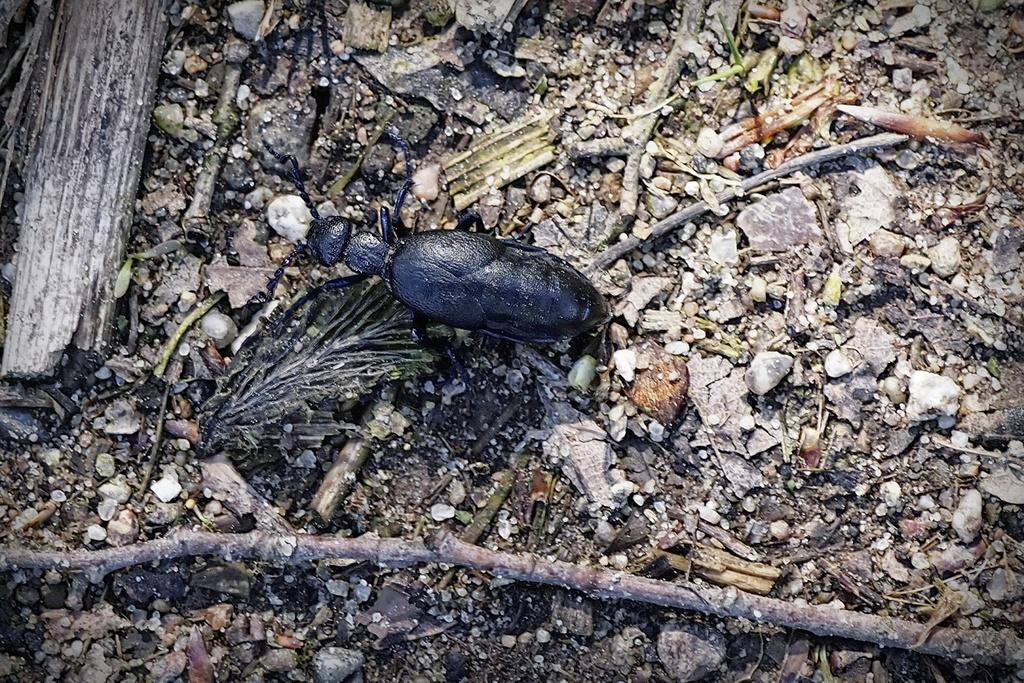What type of insect can be seen in the image? There is a black insect in the image. What is the condition of the surface where the insect is located? The insect is on a messy surface. What other objects can be seen in the image? There are stones and dry branches present in the image. What is the overall appearance of the image? There is a lot of dust in the image. What type of voice can be heard coming from the rabbit in the image? There is no rabbit present in the image, so it is not possible to determine what type of voice might be heard. 